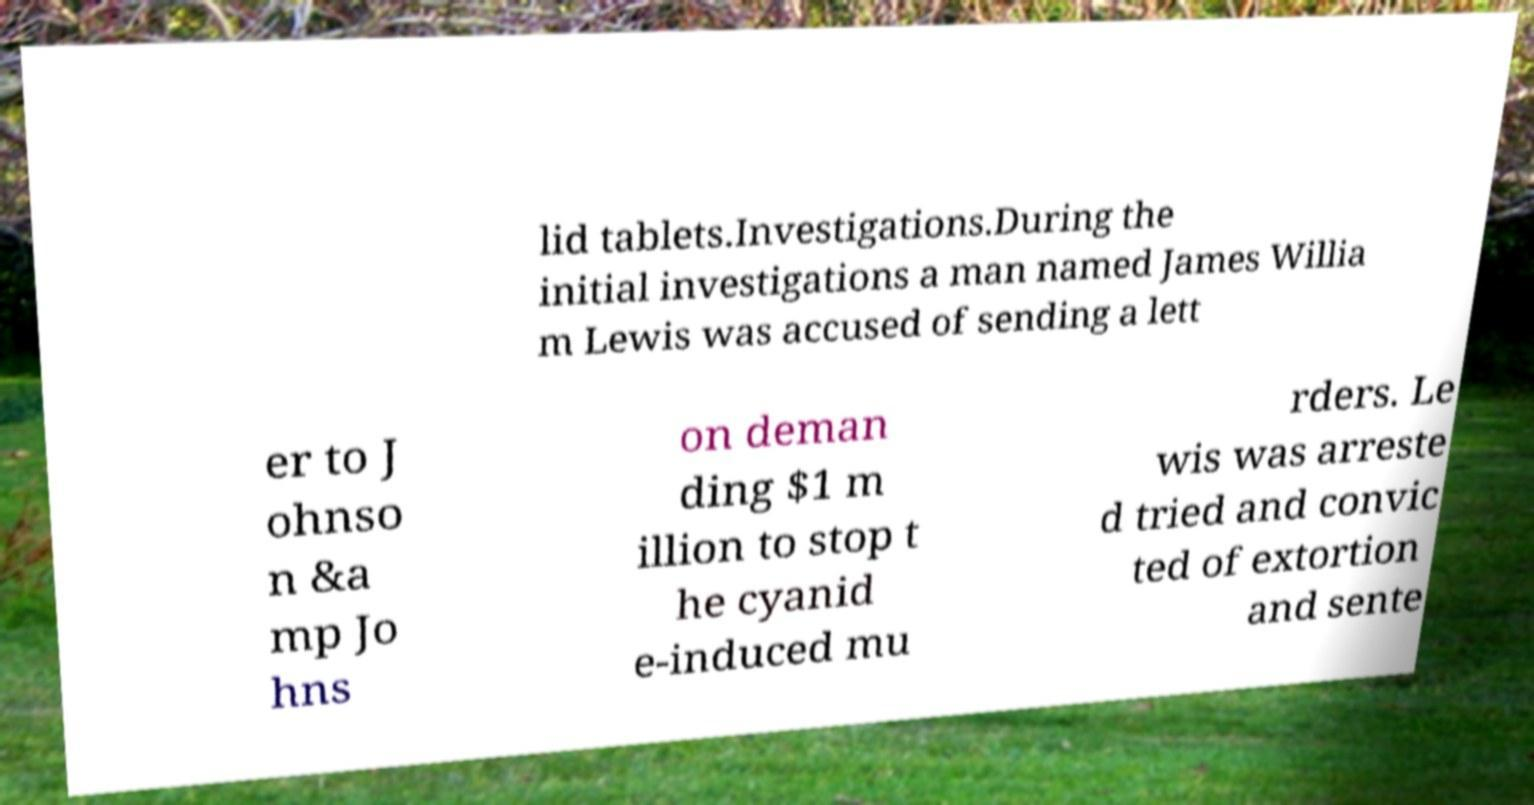Please read and relay the text visible in this image. What does it say? lid tablets.Investigations.During the initial investigations a man named James Willia m Lewis was accused of sending a lett er to J ohnso n &a mp Jo hns on deman ding $1 m illion to stop t he cyanid e-induced mu rders. Le wis was arreste d tried and convic ted of extortion and sente 